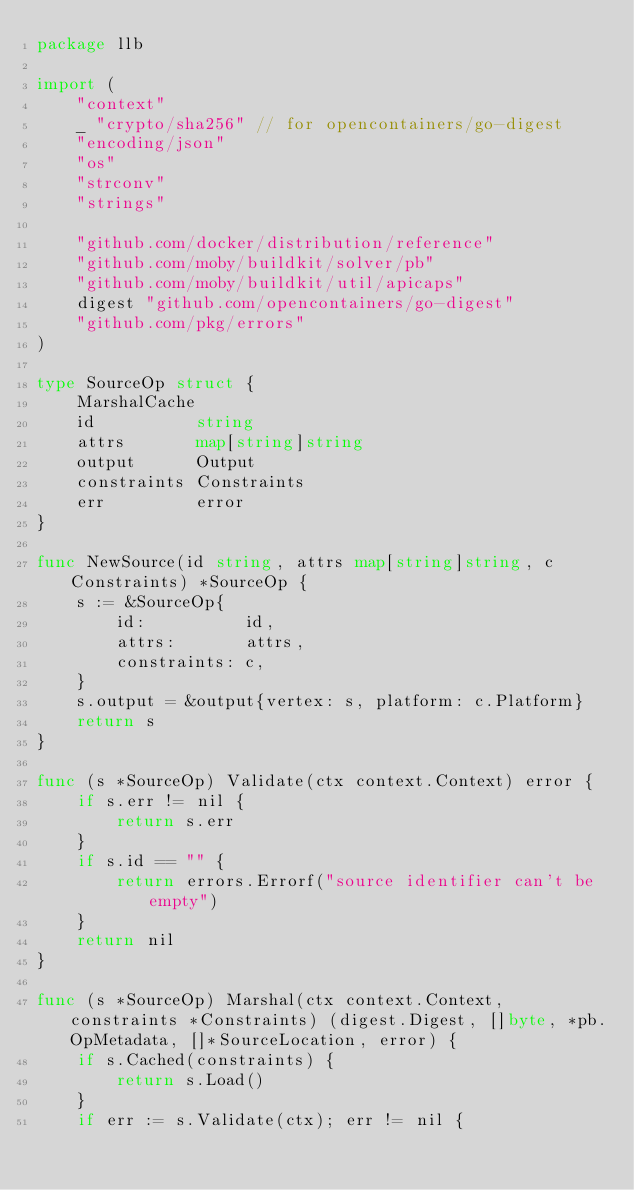<code> <loc_0><loc_0><loc_500><loc_500><_Go_>package llb

import (
	"context"
	_ "crypto/sha256" // for opencontainers/go-digest
	"encoding/json"
	"os"
	"strconv"
	"strings"

	"github.com/docker/distribution/reference"
	"github.com/moby/buildkit/solver/pb"
	"github.com/moby/buildkit/util/apicaps"
	digest "github.com/opencontainers/go-digest"
	"github.com/pkg/errors"
)

type SourceOp struct {
	MarshalCache
	id          string
	attrs       map[string]string
	output      Output
	constraints Constraints
	err         error
}

func NewSource(id string, attrs map[string]string, c Constraints) *SourceOp {
	s := &SourceOp{
		id:          id,
		attrs:       attrs,
		constraints: c,
	}
	s.output = &output{vertex: s, platform: c.Platform}
	return s
}

func (s *SourceOp) Validate(ctx context.Context) error {
	if s.err != nil {
		return s.err
	}
	if s.id == "" {
		return errors.Errorf("source identifier can't be empty")
	}
	return nil
}

func (s *SourceOp) Marshal(ctx context.Context, constraints *Constraints) (digest.Digest, []byte, *pb.OpMetadata, []*SourceLocation, error) {
	if s.Cached(constraints) {
		return s.Load()
	}
	if err := s.Validate(ctx); err != nil {</code> 